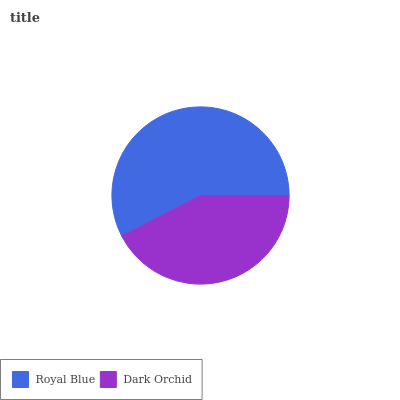Is Dark Orchid the minimum?
Answer yes or no. Yes. Is Royal Blue the maximum?
Answer yes or no. Yes. Is Dark Orchid the maximum?
Answer yes or no. No. Is Royal Blue greater than Dark Orchid?
Answer yes or no. Yes. Is Dark Orchid less than Royal Blue?
Answer yes or no. Yes. Is Dark Orchid greater than Royal Blue?
Answer yes or no. No. Is Royal Blue less than Dark Orchid?
Answer yes or no. No. Is Royal Blue the high median?
Answer yes or no. Yes. Is Dark Orchid the low median?
Answer yes or no. Yes. Is Dark Orchid the high median?
Answer yes or no. No. Is Royal Blue the low median?
Answer yes or no. No. 